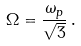Convert formula to latex. <formula><loc_0><loc_0><loc_500><loc_500>\Omega = \frac { \omega _ { p } } { \sqrt { 3 } } \, .</formula> 